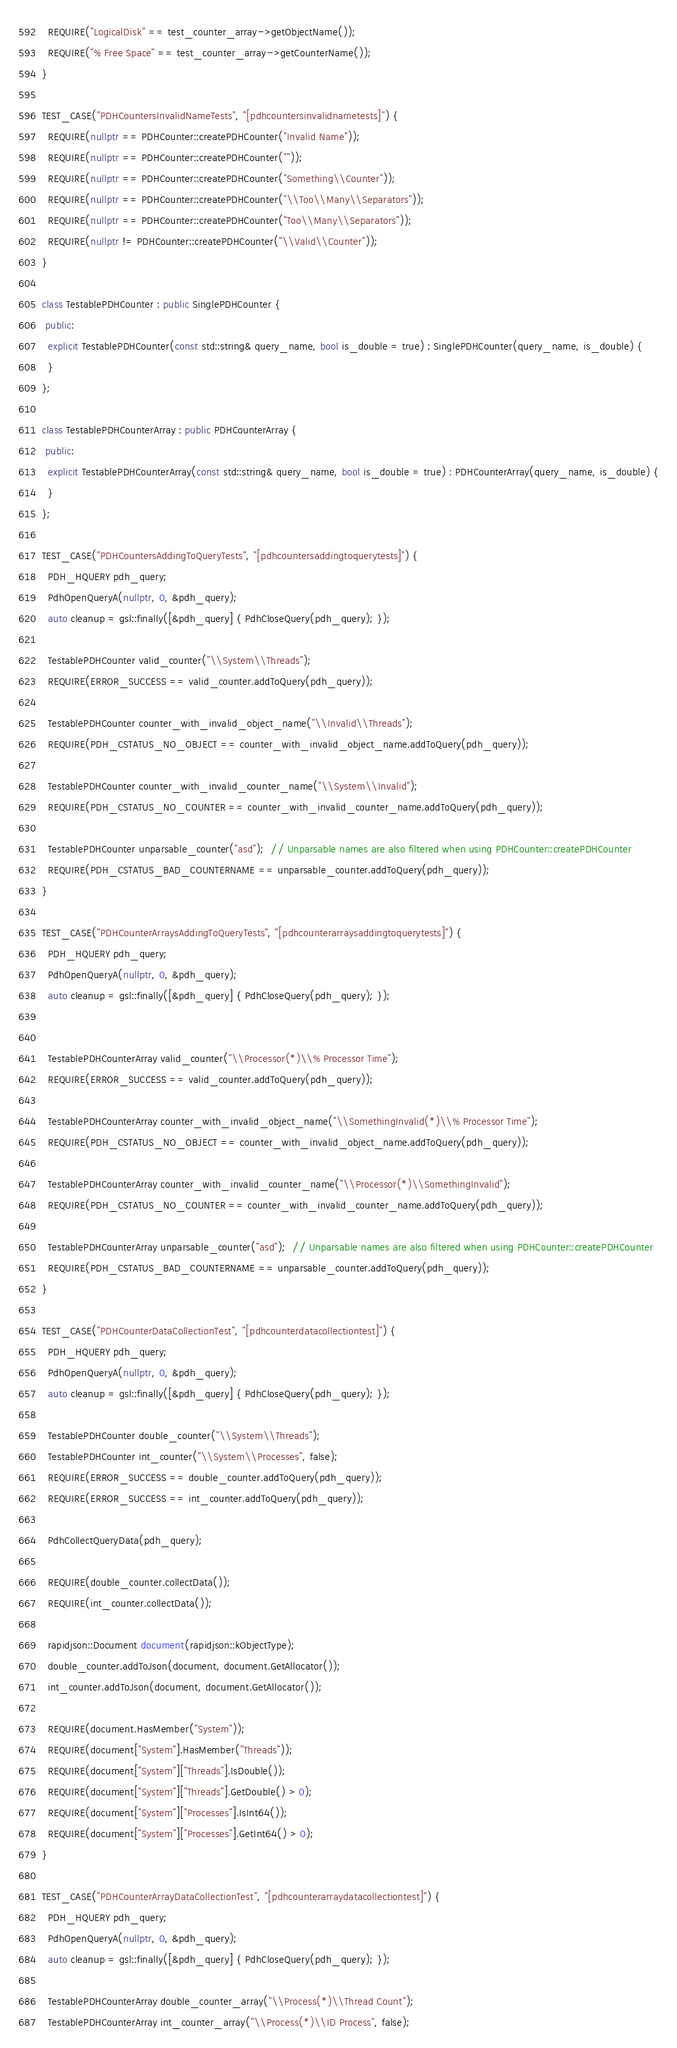Convert code to text. <code><loc_0><loc_0><loc_500><loc_500><_C++_>  REQUIRE("LogicalDisk" == test_counter_array->getObjectName());
  REQUIRE("% Free Space" == test_counter_array->getCounterName());
}

TEST_CASE("PDHCountersInvalidNameTests", "[pdhcountersinvalidnametests]") {
  REQUIRE(nullptr == PDHCounter::createPDHCounter("Invalid Name"));
  REQUIRE(nullptr == PDHCounter::createPDHCounter(""));
  REQUIRE(nullptr == PDHCounter::createPDHCounter("Something\\Counter"));
  REQUIRE(nullptr == PDHCounter::createPDHCounter("\\Too\\Many\\Separators"));
  REQUIRE(nullptr == PDHCounter::createPDHCounter("Too\\Many\\Separators"));
  REQUIRE(nullptr != PDHCounter::createPDHCounter("\\Valid\\Counter"));
}

class TestablePDHCounter : public SinglePDHCounter {
 public:
  explicit TestablePDHCounter(const std::string& query_name, bool is_double = true) : SinglePDHCounter(query_name, is_double) {
  }
};

class TestablePDHCounterArray : public PDHCounterArray {
 public:
  explicit TestablePDHCounterArray(const std::string& query_name, bool is_double = true) : PDHCounterArray(query_name, is_double) {
  }
};

TEST_CASE("PDHCountersAddingToQueryTests", "[pdhcountersaddingtoquerytests]") {
  PDH_HQUERY pdh_query;
  PdhOpenQueryA(nullptr, 0, &pdh_query);
  auto cleanup = gsl::finally([&pdh_query] { PdhCloseQuery(pdh_query); });

  TestablePDHCounter valid_counter("\\System\\Threads");
  REQUIRE(ERROR_SUCCESS == valid_counter.addToQuery(pdh_query));

  TestablePDHCounter counter_with_invalid_object_name("\\Invalid\\Threads");
  REQUIRE(PDH_CSTATUS_NO_OBJECT == counter_with_invalid_object_name.addToQuery(pdh_query));

  TestablePDHCounter counter_with_invalid_counter_name("\\System\\Invalid");
  REQUIRE(PDH_CSTATUS_NO_COUNTER == counter_with_invalid_counter_name.addToQuery(pdh_query));

  TestablePDHCounter unparsable_counter("asd");  // Unparsable names are also filtered when using PDHCounter::createPDHCounter
  REQUIRE(PDH_CSTATUS_BAD_COUNTERNAME == unparsable_counter.addToQuery(pdh_query));
}

TEST_CASE("PDHCounterArraysAddingToQueryTests", "[pdhcounterarraysaddingtoquerytests]") {
  PDH_HQUERY pdh_query;
  PdhOpenQueryA(nullptr, 0, &pdh_query);
  auto cleanup = gsl::finally([&pdh_query] { PdhCloseQuery(pdh_query); });


  TestablePDHCounterArray valid_counter("\\Processor(*)\\% Processor Time");
  REQUIRE(ERROR_SUCCESS == valid_counter.addToQuery(pdh_query));

  TestablePDHCounterArray counter_with_invalid_object_name("\\SomethingInvalid(*)\\% Processor Time");
  REQUIRE(PDH_CSTATUS_NO_OBJECT == counter_with_invalid_object_name.addToQuery(pdh_query));

  TestablePDHCounterArray counter_with_invalid_counter_name("\\Processor(*)\\SomethingInvalid");
  REQUIRE(PDH_CSTATUS_NO_COUNTER == counter_with_invalid_counter_name.addToQuery(pdh_query));

  TestablePDHCounterArray unparsable_counter("asd");  // Unparsable names are also filtered when using PDHCounter::createPDHCounter
  REQUIRE(PDH_CSTATUS_BAD_COUNTERNAME == unparsable_counter.addToQuery(pdh_query));
}

TEST_CASE("PDHCounterDataCollectionTest", "[pdhcounterdatacollectiontest]") {
  PDH_HQUERY pdh_query;
  PdhOpenQueryA(nullptr, 0, &pdh_query);
  auto cleanup = gsl::finally([&pdh_query] { PdhCloseQuery(pdh_query); });

  TestablePDHCounter double_counter("\\System\\Threads");
  TestablePDHCounter int_counter("\\System\\Processes", false);
  REQUIRE(ERROR_SUCCESS == double_counter.addToQuery(pdh_query));
  REQUIRE(ERROR_SUCCESS == int_counter.addToQuery(pdh_query));

  PdhCollectQueryData(pdh_query);

  REQUIRE(double_counter.collectData());
  REQUIRE(int_counter.collectData());

  rapidjson::Document document(rapidjson::kObjectType);
  double_counter.addToJson(document, document.GetAllocator());
  int_counter.addToJson(document, document.GetAllocator());

  REQUIRE(document.HasMember("System"));
  REQUIRE(document["System"].HasMember("Threads"));
  REQUIRE(document["System"]["Threads"].IsDouble());
  REQUIRE(document["System"]["Threads"].GetDouble() > 0);
  REQUIRE(document["System"]["Processes"].IsInt64());
  REQUIRE(document["System"]["Processes"].GetInt64() > 0);
}

TEST_CASE("PDHCounterArrayDataCollectionTest", "[pdhcounterarraydatacollectiontest]") {
  PDH_HQUERY pdh_query;
  PdhOpenQueryA(nullptr, 0, &pdh_query);
  auto cleanup = gsl::finally([&pdh_query] { PdhCloseQuery(pdh_query); });

  TestablePDHCounterArray double_counter_array("\\Process(*)\\Thread Count");
  TestablePDHCounterArray int_counter_array("\\Process(*)\\ID Process", false);</code> 